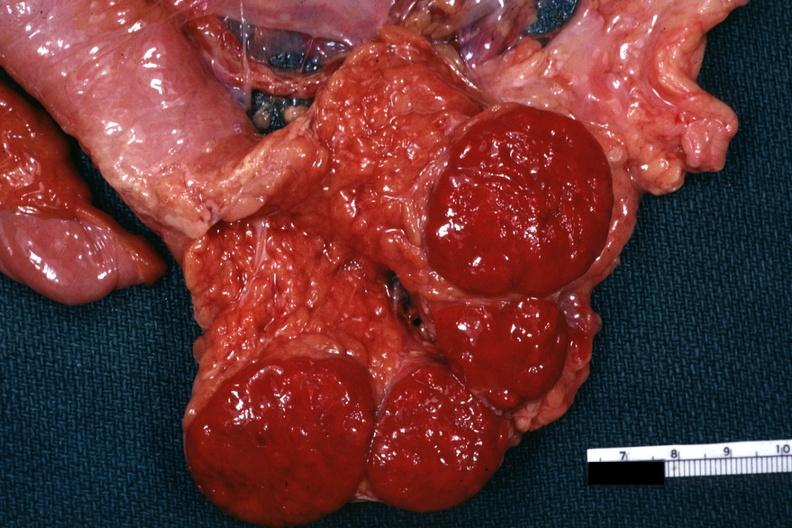s twins present?
Answer the question using a single word or phrase. No 